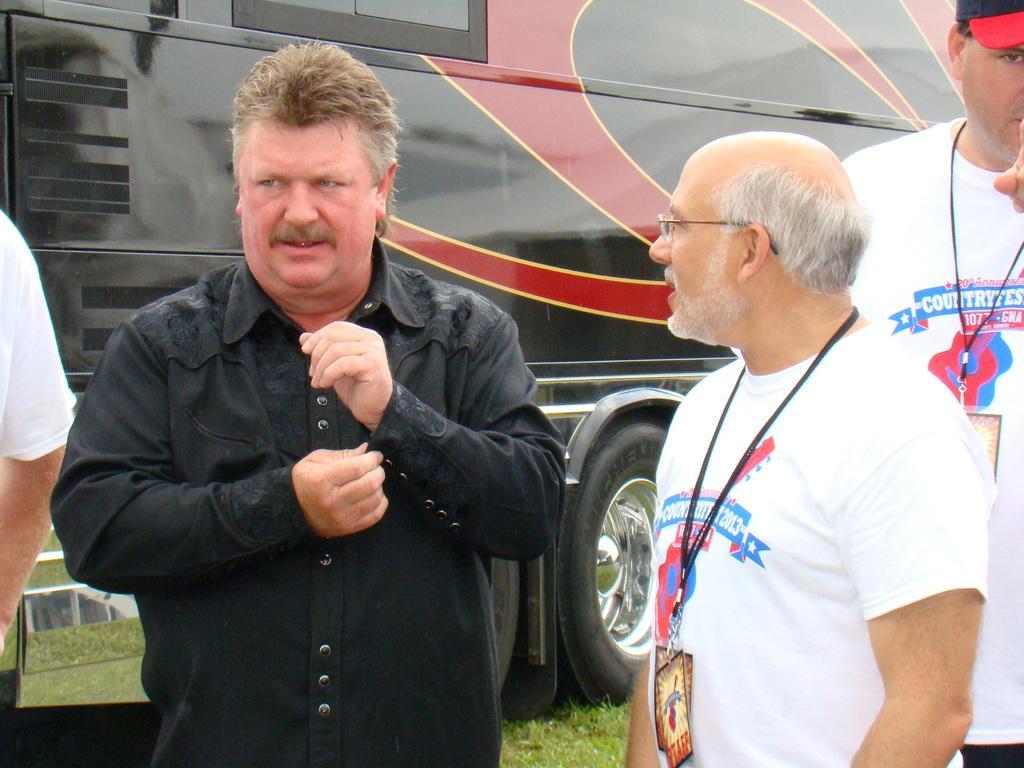Describe this image in one or two sentences. In the picture there is a man and he is wearing black shirt and around the man there are three men,they are wearing same shirt and also id cards,behind the man there is a vehicle parked on the grass. 